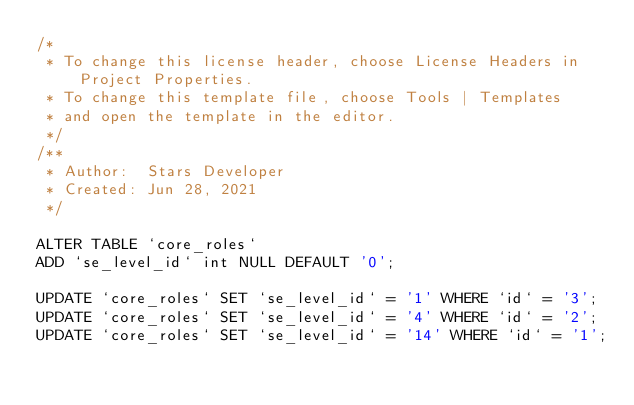<code> <loc_0><loc_0><loc_500><loc_500><_SQL_>/* 
 * To change this license header, choose License Headers in Project Properties.
 * To change this template file, choose Tools | Templates
 * and open the template in the editor.
 */
/**
 * Author:  Stars Developer
 * Created: Jun 28, 2021
 */

ALTER TABLE `core_roles`
ADD `se_level_id` int NULL DEFAULT '0';

UPDATE `core_roles` SET `se_level_id` = '1' WHERE `id` = '3';
UPDATE `core_roles` SET `se_level_id` = '4' WHERE `id` = '2';
UPDATE `core_roles` SET `se_level_id` = '14' WHERE `id` = '1';</code> 